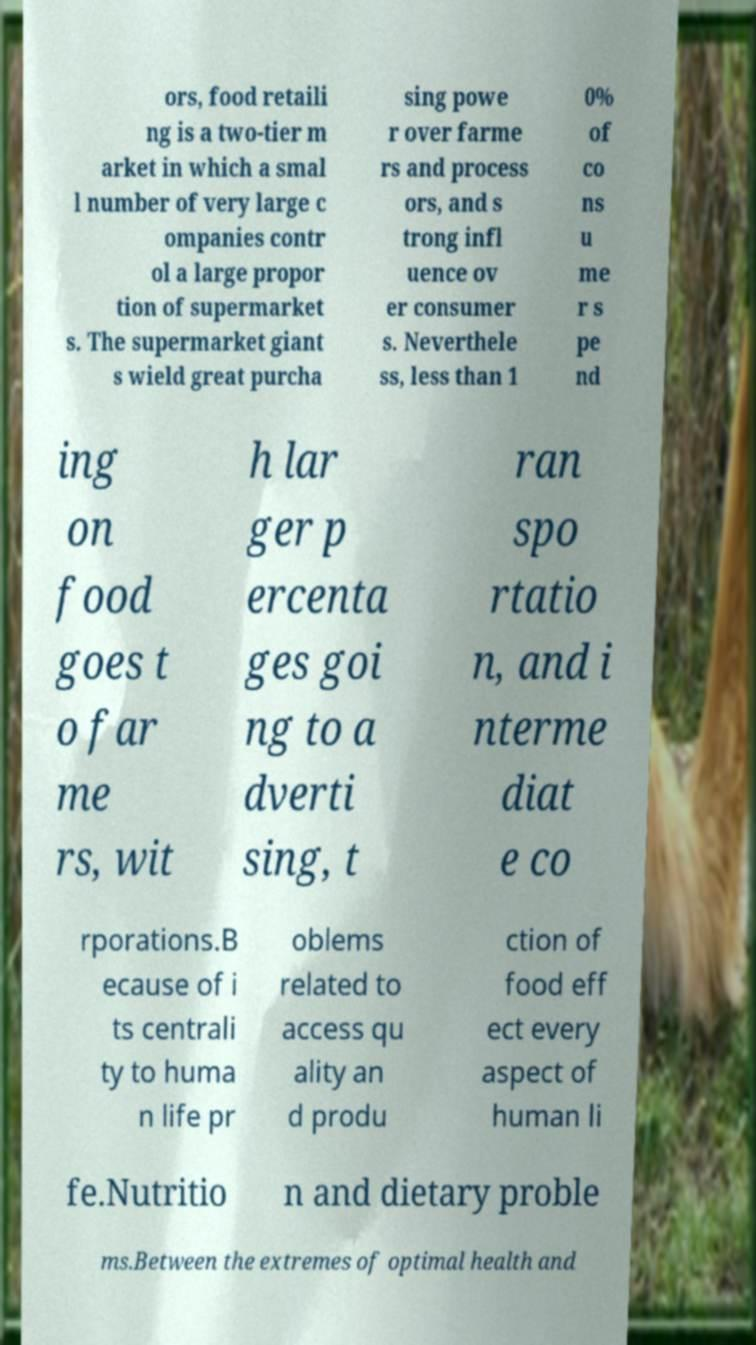There's text embedded in this image that I need extracted. Can you transcribe it verbatim? ors, food retaili ng is a two-tier m arket in which a smal l number of very large c ompanies contr ol a large propor tion of supermarket s. The supermarket giant s wield great purcha sing powe r over farme rs and process ors, and s trong infl uence ov er consumer s. Neverthele ss, less than 1 0% of co ns u me r s pe nd ing on food goes t o far me rs, wit h lar ger p ercenta ges goi ng to a dverti sing, t ran spo rtatio n, and i nterme diat e co rporations.B ecause of i ts centrali ty to huma n life pr oblems related to access qu ality an d produ ction of food eff ect every aspect of human li fe.Nutritio n and dietary proble ms.Between the extremes of optimal health and 